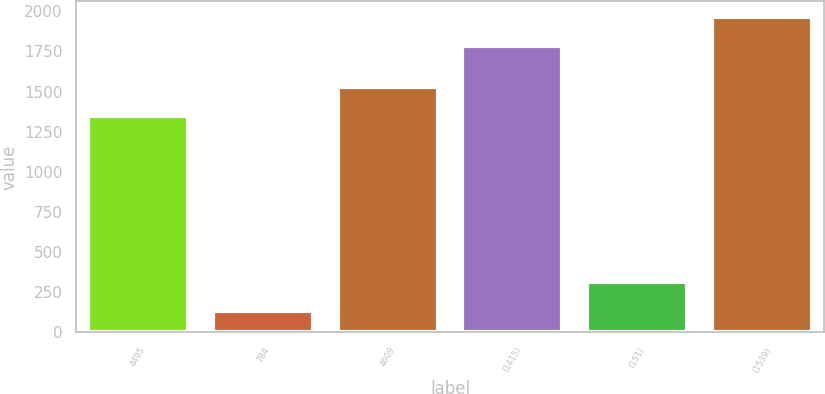<chart> <loc_0><loc_0><loc_500><loc_500><bar_chart><fcel>4495<fcel>784<fcel>4609<fcel>(1415)<fcel>(151)<fcel>(1539)<nl><fcel>1349<fcel>134<fcel>1529.8<fcel>1783<fcel>314.8<fcel>1963.8<nl></chart> 